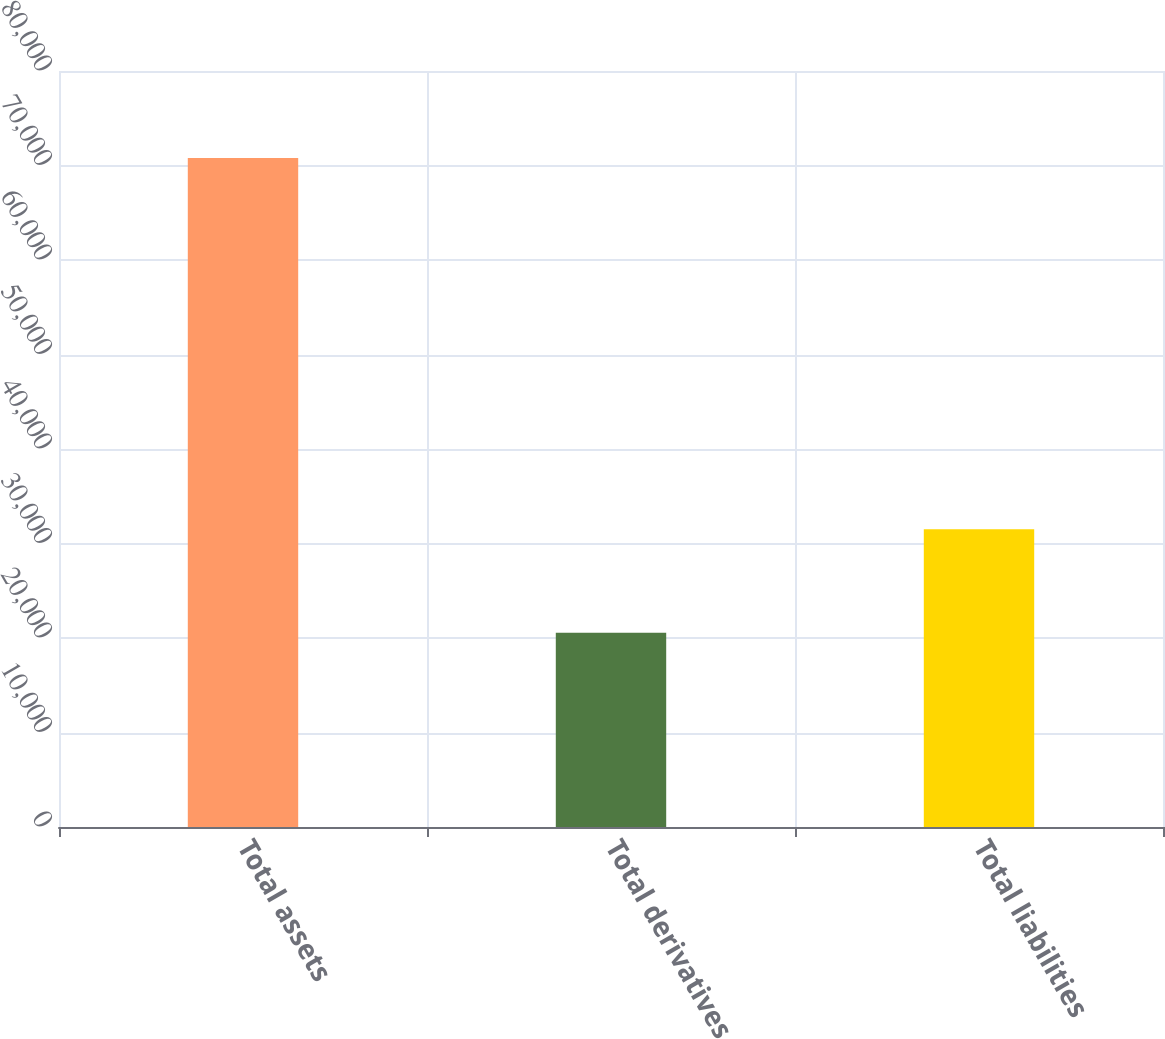Convert chart. <chart><loc_0><loc_0><loc_500><loc_500><bar_chart><fcel>Total assets<fcel>Total derivatives<fcel>Total liabilities<nl><fcel>70784<fcel>20566<fcel>31497<nl></chart> 